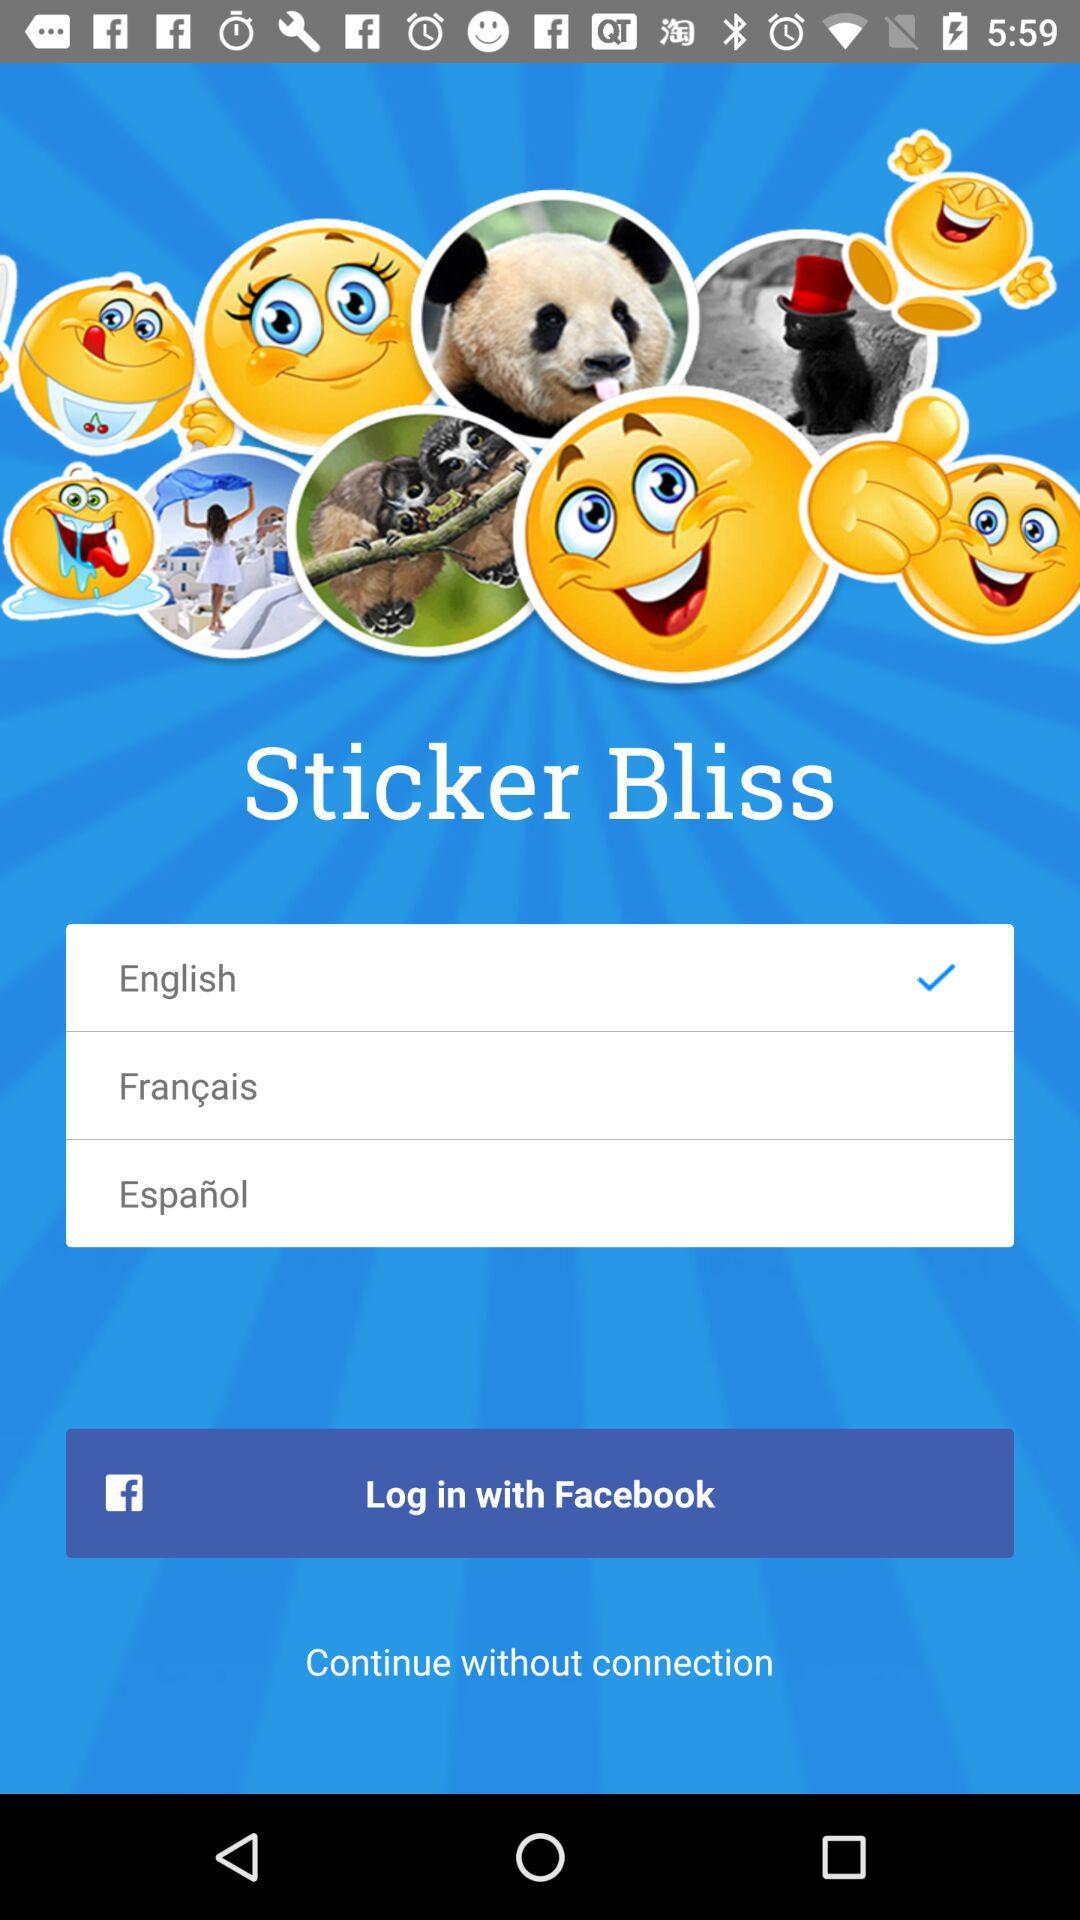How can we log in? You can log in with "Facebook". 